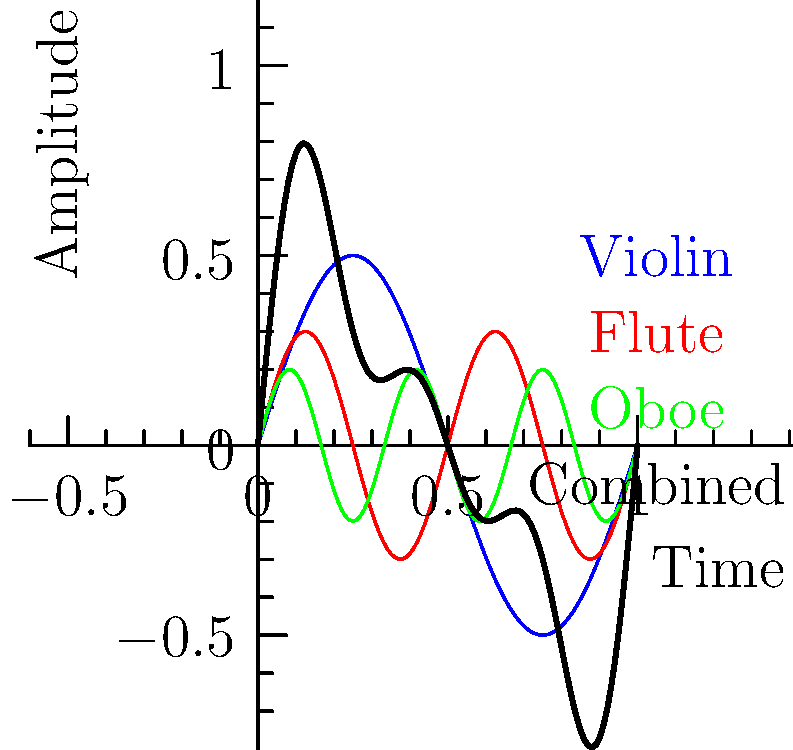The graph shows the waveform patterns of three orchestral instruments (violin, flute, and oboe) and their combined waveform. If the fundamental frequency of the violin is 440 Hz, what is the frequency of the third harmonic of the oboe? To solve this problem, we need to follow these steps:

1. Identify the relative frequencies of the instruments:
   - Violin (blue): 1 cycle per unit time
   - Flute (red): 2 cycles per unit time
   - Oboe (green): 3 cycles per unit time

2. Determine the relationship between the instruments' frequencies:
   - Flute frequency = 2 * Violin frequency
   - Oboe frequency = 3 * Violin frequency

3. Calculate the oboe's fundamental frequency:
   - Violin fundamental frequency = 440 Hz
   - Oboe fundamental frequency = 3 * 440 Hz = 1320 Hz

4. Determine the third harmonic of the oboe:
   - The third harmonic is 3 times the fundamental frequency
   - Third harmonic of oboe = 3 * 1320 Hz = 3960 Hz

Therefore, the frequency of the third harmonic of the oboe is 3960 Hz.
Answer: 3960 Hz 